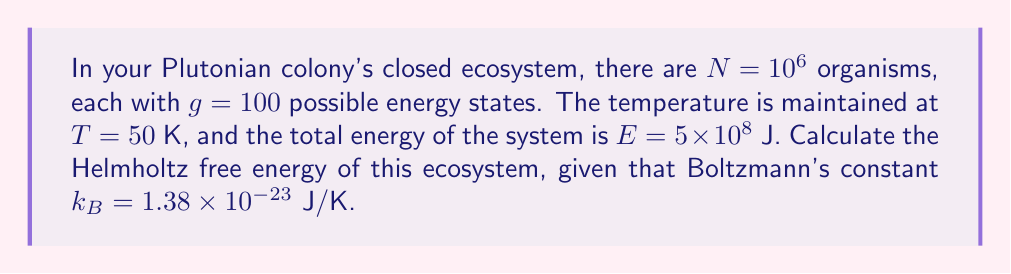Show me your answer to this math problem. To calculate the Helmholtz free energy, we'll use the formula:

$$F = E - TS$$

where $F$ is the Helmholtz free energy, $E$ is the total energy, $T$ is the temperature, and $S$ is the entropy.

We need to calculate the entropy $S$ first:

1) The number of microstates $\Omega$ for this system is:

   $$\Omega = g^N = 100^{10^6}$$

2) Using Boltzmann's entropy formula:

   $$S = k_B \ln \Omega$$

3) Substituting the values:

   $$S = (1.38 \times 10^{-23} \text{ J/K}) \ln(100^{10^6})$$

4) Simplify:

   $$S = (1.38 \times 10^{-23} \text{ J/K}) (10^6 \ln 100)$$
   $$S = (1.38 \times 10^{-23} \text{ J/K}) (10^6 \times 4.60517)$$
   $$S = 6.35 \times 10^{-16} \text{ J/K}$$

5) Now we can calculate the Helmholtz free energy:

   $$F = E - TS$$
   $$F = 5 \times 10^8 \text{ J} - (50 \text{ K})(6.35 \times 10^{-16} \text{ J/K})$$
   $$F = 5 \times 10^8 \text{ J} - 3.175 \times 10^{-14} \text{ J}$$

6) The second term is negligible compared to the first, so:

   $$F \approx 5 \times 10^8 \text{ J}$$
Answer: $5 \times 10^8$ J 